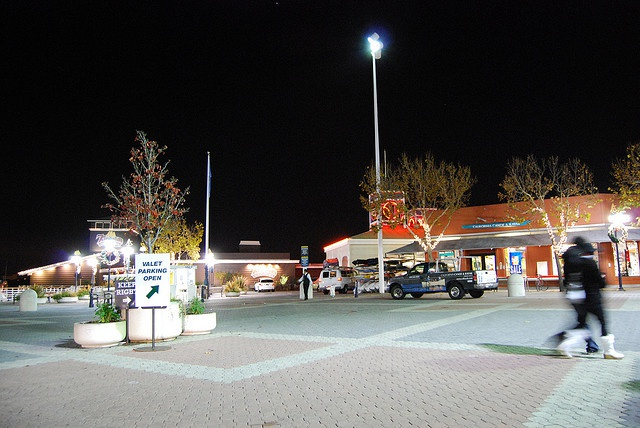Describe the objects in this image and their specific colors. I can see potted plant in black, white, gray, and olive tones, people in black, lavender, gray, and darkgray tones, truck in black, gray, white, and darkgray tones, potted plant in black, white, darkgray, darkgreen, and gray tones, and potted plant in black, white, darkgray, green, and olive tones in this image. 